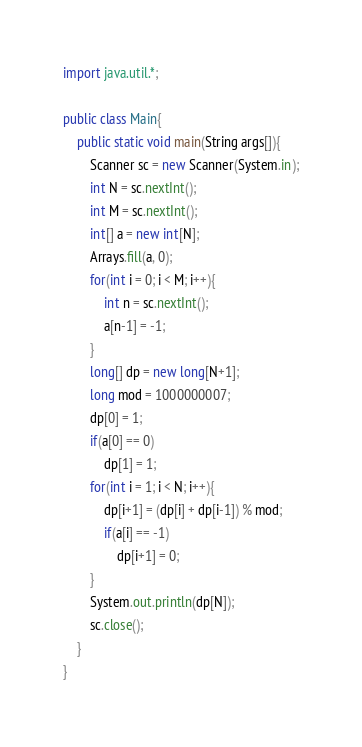Convert code to text. <code><loc_0><loc_0><loc_500><loc_500><_Java_>import java.util.*;

public class Main{
    public static void main(String args[]){
        Scanner sc = new Scanner(System.in);
        int N = sc.nextInt();
        int M = sc.nextInt();
        int[] a = new int[N];
        Arrays.fill(a, 0);
        for(int i = 0; i < M; i++){
            int n = sc.nextInt();
            a[n-1] = -1;
        }
        long[] dp = new long[N+1];
        long mod = 1000000007;
        dp[0] = 1;
        if(a[0] == 0)
            dp[1] = 1;
        for(int i = 1; i < N; i++){
            dp[i+1] = (dp[i] + dp[i-1]) % mod;
            if(a[i] == -1)
                dp[i+1] = 0;
        }
        System.out.println(dp[N]);
        sc.close();
    }
}
</code> 